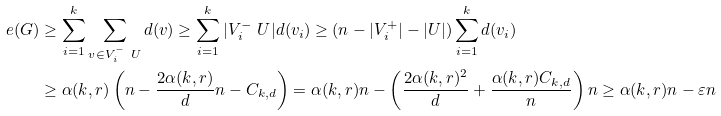Convert formula to latex. <formula><loc_0><loc_0><loc_500><loc_500>e ( G ) & \geq \sum _ { i = 1 } ^ { k } \sum _ { v \in V _ { i } ^ { - } \ U } d ( v ) \geq \sum _ { i = 1 } ^ { k } | V _ { i } ^ { - } \ U | d ( v _ { i } ) \geq ( n - | V _ { i } ^ { + } | - | U | ) \sum _ { i = 1 } ^ { k } d ( v _ { i } ) \\ & \geq \alpha ( k , r ) \left ( n - \frac { 2 \alpha ( k , r ) } { d } n - C _ { k , d } \right ) = \alpha ( k , r ) n - \left ( \frac { 2 \alpha ( k , r ) ^ { 2 } } { d } + \frac { \alpha ( k , r ) C _ { k , d } } { n } \right ) n \geq \alpha ( k , r ) n - \varepsilon n</formula> 